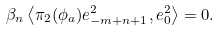Convert formula to latex. <formula><loc_0><loc_0><loc_500><loc_500>\beta _ { n } \left \langle \pi _ { 2 } ( \phi _ { a } ) e _ { - m + n + 1 } ^ { 2 } , e _ { 0 } ^ { 2 } \right \rangle = 0 .</formula> 